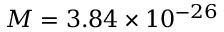Convert formula to latex. <formula><loc_0><loc_0><loc_500><loc_500>M = 3 . 8 4 \times 1 0 ^ { - 2 6 }</formula> 